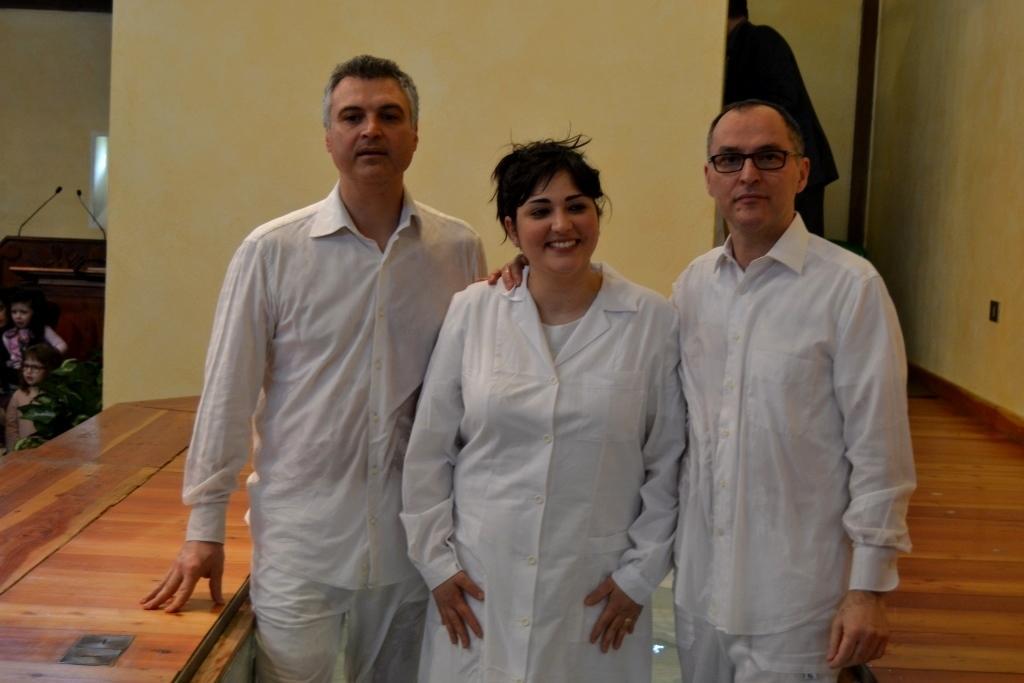Describe this image in one or two sentences. In this picture I can observe three members. Two of them are men and one of them is a woman. She is smiling. All of them are wearing white color dresses. On the left side I can observe a desk. In the background there is a wall. 